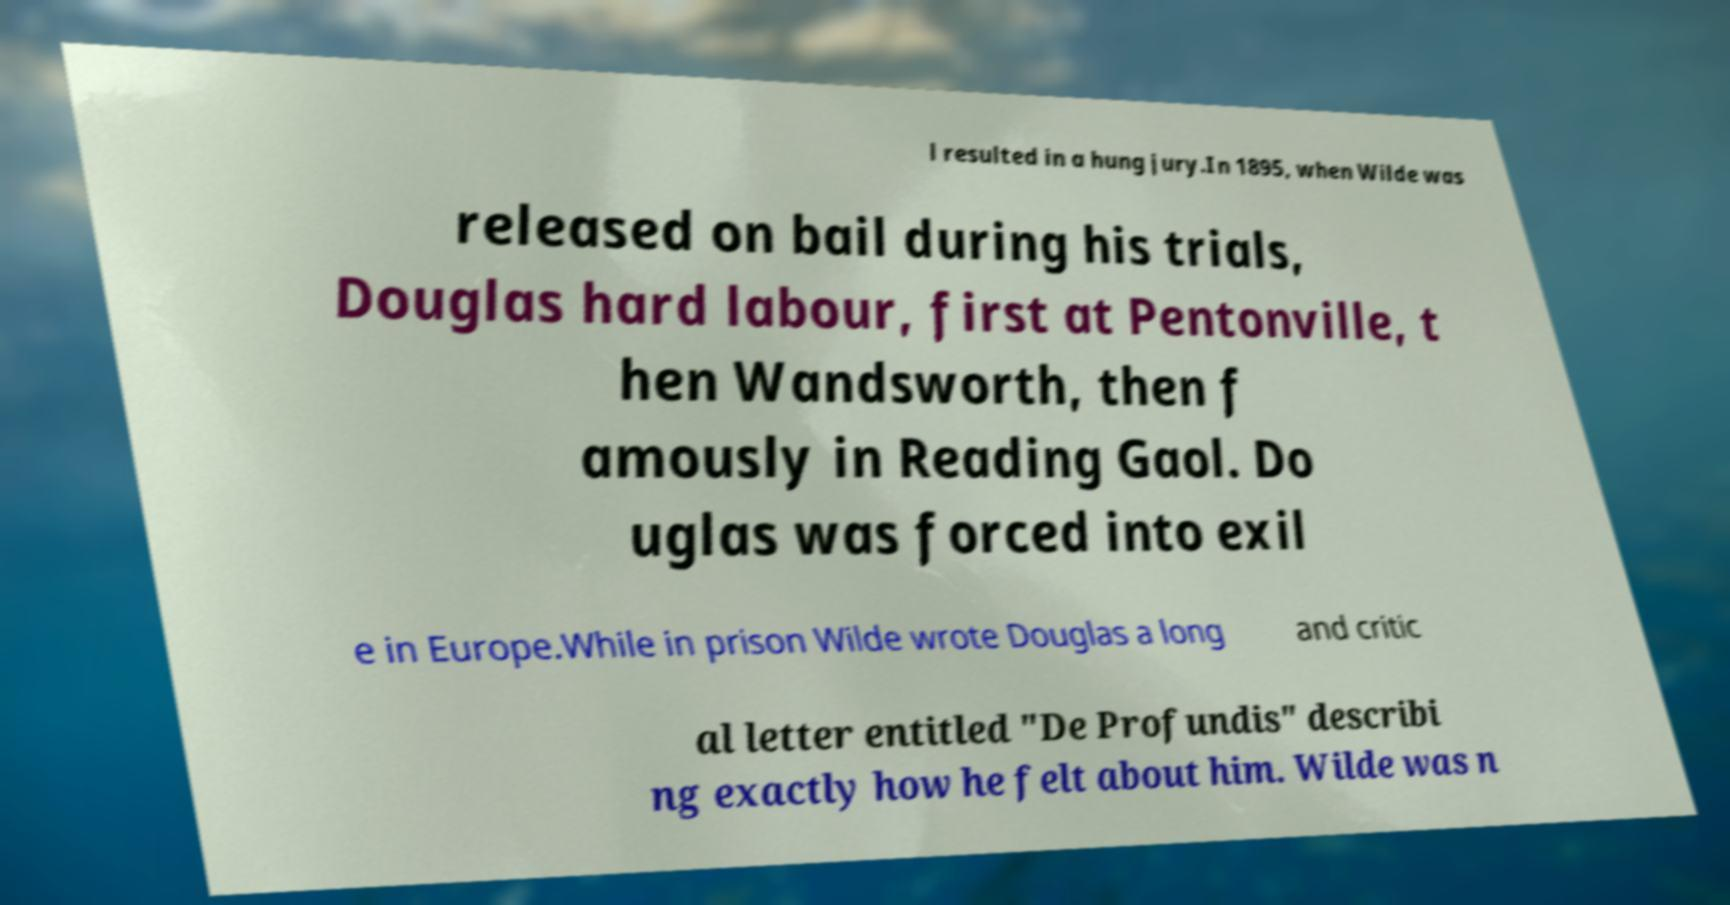For documentation purposes, I need the text within this image transcribed. Could you provide that? l resulted in a hung jury.In 1895, when Wilde was released on bail during his trials, Douglas hard labour, first at Pentonville, t hen Wandsworth, then f amously in Reading Gaol. Do uglas was forced into exil e in Europe.While in prison Wilde wrote Douglas a long and critic al letter entitled "De Profundis" describi ng exactly how he felt about him. Wilde was n 